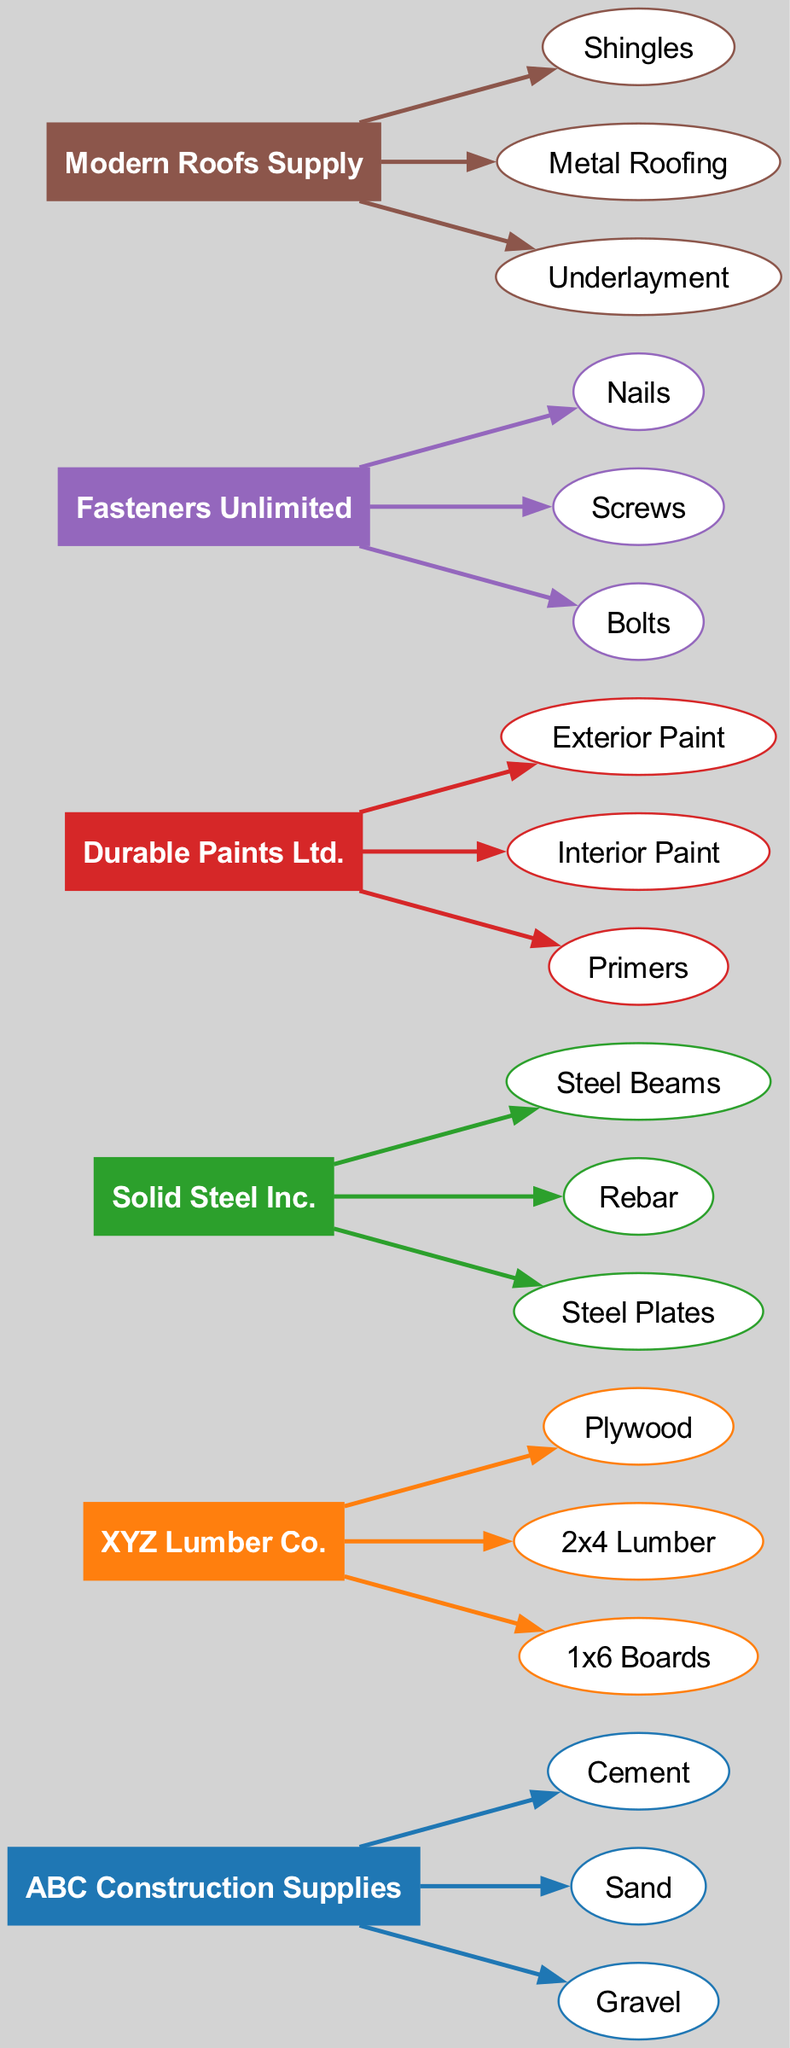What are the total number of suppliers in the diagram? The diagram lists six different suppliers visible as nodes. Counting these, we find ABC Construction Supplies, XYZ Lumber Co., Solid Steel Inc., Durable Paints Ltd., Fasteners Unlimited, and Modern Roofs Supply, making a total of six suppliers.
Answer: 6 Which supplier provides "Plywood"? By scanning the supplier nodes and their respective material connections, "Plywood" is linked with the supplier "XYZ Lumber Co.", confirming that they provide this specific material.
Answer: XYZ Lumber Co How many materials does "Fasteners Unlimited" supply? Upon analyzing the connections from "Fasteners Unlimited," we see that there are three materials linked: "Nails," "Screws," and "Bolts." Thus, the count of materials from this supplier is three.
Answer: 3 Which supplier has the most materials associated with it? By reviewing the list of materials supplied by each supplier, "ABC Construction Supplies" has three materials (Cement, Sand, Gravel), "XYZ Lumber Co." has three materials, "Solid Steel Inc." has three materials, "Durable Paints Ltd." has three materials, "Fasteners Unlimited" has three materials, and "Modern Roofs Supply" has three materials. All suppliers have the same amount, which is three.
Answer: None (all have the same number) Which material is associated with "Solid Steel Inc."? Looking at the flow from "Solid Steel Inc.," the materials associated with this supplier are "Steel Beams," "Rebar," and "Steel Plates," confirming all the materials supplied by them. The answer would be any of these materials, so responding with just one, such as "Steel Beams," is appropriate.
Answer: Steel Beams What relationship exists between "Durable Paints Ltd." and the materials? The materials connected to "Durable Paints Ltd." are "Exterior Paint," "Interior Paint," and "Primers." These materials flow directly from the supplier, establishing the relationship of supply.
Answer: Supplies How many materials are connected overall in the diagram? Accumulating all materials listed under each supplier, we arrive at a total: ABC Construction Supplies has three, XYZ Lumber Co. has three, Solid Steel Inc. has three, Durable Paints Ltd. has three, Fasteners Unlimited has three, and Modern Roofs Supply has three, leading to a total of 18 materials.
Answer: 18 Which supplier has a unique color representation in the diagram? Each supplier is represented by a distinct color, which visually differentiates them. Observing the colors used, we see that while they are unique to each supplier, there is no overlap. The distinct colors indicate their individual roles, thus "none" is appropriate since they all have unique representations.
Answer: None (all unique) 